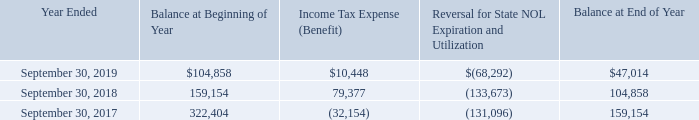The valuation allowance activity for the years ended September 30, 2019, 2018, and 2017 is as follows:
The Company completed an Internal Revenue Code Section 382 analysis of the loss carry forwards in 2009 and determined then that all of the Company’s loss carry forwards are utilizable and not restricted under Section 382. The Company has not updated its Section 382 analysis subsequent to 2009 and does not believe there have been any events subsequent to 2009 that would impact the analysis.
The Company is required to recognize the financial statement benefit of a tax position only after determining that the relevant tax authority would more likely than not sustain the position following an audit. For tax positions meeting the more likely than not threshold, the amount recognized in the financial statements is the largest benefit that has a greater than 50 percent likelihood of being realized upon ultimate settlement with the relevant tax authority. The Company applies the interpretation to all tax positions for which the statute of limitations remained open. The Company had no liability for unrecognized tax benefits and did not recognize any interest or penalties during the years ended September 30, 2019, 2018, or 2017.
The Company is subject to income taxes in the U.S. federal jurisdiction, and various state jurisdictions. Tax regulations within each jurisdiction are subject to the interpretation of the related tax laws and regulations and require significant judgment to apply. With few exceptions, the Company is no longer subject to U.S. federal, state and local, income tax examinations by tax authorities for fiscal years ending prior to 2004. We are generally subject to U.S. federal and state tax examinations for all tax years since 2003 due to our net operating loss carryforwards and the utilization of the carryforwards in years still open under statute. During the year ended September 30, 2018, the Company was examined by the U.S. Internal Revenue Service for fiscal year 2016. This examination resulted in no adjustments. The Company changed its fiscal year end in 2007 from March 31 to September 30.
What is the balance at the beginning of 2019 and 2018 respectively? $104,858, 159,154. What is the balance at the beginning of 2018 and 2017 respectively? 159,154, 322,404. What is the income tax expense of fiscal years 2019 and 2018 respectively? $10,448, 79,377. What is the percentage change in the end-of-year valuation allowance from 2018 to 2019?
Answer scale should be: percent. (47,014-104,858)/104,858
Answer: -55.16. What is the percentage change in the end-of-year valuation allowance from 2017 to 2018?
Answer scale should be: percent. (104,858-159,154)/159,154
Answer: -34.12. What is the percentage change in the income tax expense from 2018 to 2019?
Answer scale should be: percent. (10,448-79,377)/79,377
Answer: -86.84. 